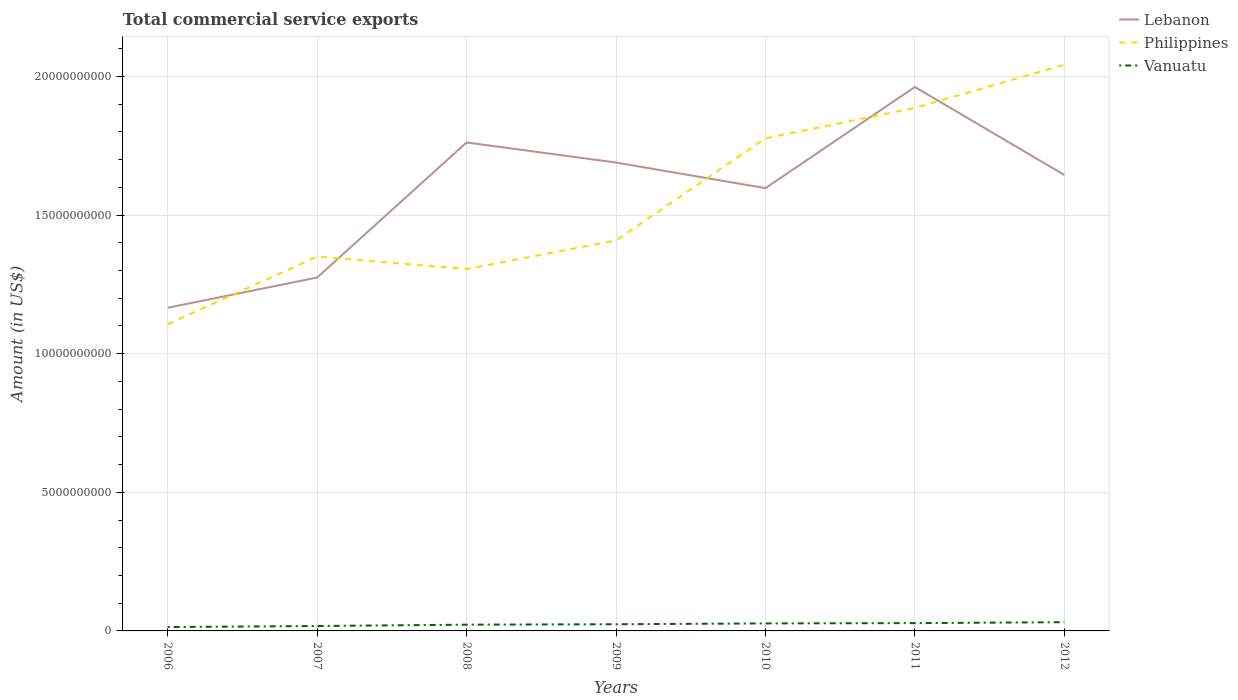Does the line corresponding to Vanuatu intersect with the line corresponding to Philippines?
Offer a terse response. No. Is the number of lines equal to the number of legend labels?
Make the answer very short. Yes. Across all years, what is the maximum total commercial service exports in Vanuatu?
Your response must be concise. 1.40e+08. In which year was the total commercial service exports in Lebanon maximum?
Your answer should be compact. 2006. What is the total total commercial service exports in Lebanon in the graph?
Keep it short and to the point. -4.31e+09. What is the difference between the highest and the second highest total commercial service exports in Lebanon?
Give a very brief answer. 7.96e+09. What is the difference between the highest and the lowest total commercial service exports in Lebanon?
Your response must be concise. 5. How many years are there in the graph?
Provide a short and direct response. 7. How are the legend labels stacked?
Your answer should be compact. Vertical. What is the title of the graph?
Your response must be concise. Total commercial service exports. Does "Belarus" appear as one of the legend labels in the graph?
Give a very brief answer. No. What is the label or title of the X-axis?
Give a very brief answer. Years. What is the Amount (in US$) of Lebanon in 2006?
Provide a succinct answer. 1.17e+1. What is the Amount (in US$) of Philippines in 2006?
Your answer should be very brief. 1.11e+1. What is the Amount (in US$) of Vanuatu in 2006?
Provide a succinct answer. 1.40e+08. What is the Amount (in US$) in Lebanon in 2007?
Your response must be concise. 1.27e+1. What is the Amount (in US$) of Philippines in 2007?
Provide a succinct answer. 1.35e+1. What is the Amount (in US$) of Vanuatu in 2007?
Make the answer very short. 1.77e+08. What is the Amount (in US$) of Lebanon in 2008?
Your answer should be compact. 1.76e+1. What is the Amount (in US$) of Philippines in 2008?
Give a very brief answer. 1.31e+1. What is the Amount (in US$) in Vanuatu in 2008?
Ensure brevity in your answer.  2.25e+08. What is the Amount (in US$) in Lebanon in 2009?
Your answer should be very brief. 1.69e+1. What is the Amount (in US$) in Philippines in 2009?
Keep it short and to the point. 1.41e+1. What is the Amount (in US$) in Vanuatu in 2009?
Give a very brief answer. 2.41e+08. What is the Amount (in US$) of Lebanon in 2010?
Provide a succinct answer. 1.60e+1. What is the Amount (in US$) of Philippines in 2010?
Ensure brevity in your answer.  1.78e+1. What is the Amount (in US$) in Vanuatu in 2010?
Your answer should be compact. 2.71e+08. What is the Amount (in US$) of Lebanon in 2011?
Offer a very short reply. 1.96e+1. What is the Amount (in US$) in Philippines in 2011?
Provide a succinct answer. 1.89e+1. What is the Amount (in US$) of Vanuatu in 2011?
Offer a very short reply. 2.81e+08. What is the Amount (in US$) of Lebanon in 2012?
Your answer should be very brief. 1.64e+1. What is the Amount (in US$) in Philippines in 2012?
Your answer should be very brief. 2.04e+1. What is the Amount (in US$) of Vanuatu in 2012?
Your response must be concise. 3.15e+08. Across all years, what is the maximum Amount (in US$) of Lebanon?
Keep it short and to the point. 1.96e+1. Across all years, what is the maximum Amount (in US$) in Philippines?
Your answer should be very brief. 2.04e+1. Across all years, what is the maximum Amount (in US$) in Vanuatu?
Ensure brevity in your answer.  3.15e+08. Across all years, what is the minimum Amount (in US$) of Lebanon?
Your response must be concise. 1.17e+1. Across all years, what is the minimum Amount (in US$) in Philippines?
Give a very brief answer. 1.11e+1. Across all years, what is the minimum Amount (in US$) in Vanuatu?
Keep it short and to the point. 1.40e+08. What is the total Amount (in US$) of Lebanon in the graph?
Offer a very short reply. 1.11e+11. What is the total Amount (in US$) of Philippines in the graph?
Ensure brevity in your answer.  1.09e+11. What is the total Amount (in US$) of Vanuatu in the graph?
Provide a short and direct response. 1.65e+09. What is the difference between the Amount (in US$) in Lebanon in 2006 and that in 2007?
Make the answer very short. -1.09e+09. What is the difference between the Amount (in US$) of Philippines in 2006 and that in 2007?
Ensure brevity in your answer.  -2.44e+09. What is the difference between the Amount (in US$) in Vanuatu in 2006 and that in 2007?
Make the answer very short. -3.69e+07. What is the difference between the Amount (in US$) of Lebanon in 2006 and that in 2008?
Ensure brevity in your answer.  -5.96e+09. What is the difference between the Amount (in US$) of Philippines in 2006 and that in 2008?
Give a very brief answer. -1.99e+09. What is the difference between the Amount (in US$) in Vanuatu in 2006 and that in 2008?
Give a very brief answer. -8.52e+07. What is the difference between the Amount (in US$) in Lebanon in 2006 and that in 2009?
Your answer should be compact. -5.24e+09. What is the difference between the Amount (in US$) in Philippines in 2006 and that in 2009?
Make the answer very short. -3.02e+09. What is the difference between the Amount (in US$) of Vanuatu in 2006 and that in 2009?
Your answer should be compact. -1.01e+08. What is the difference between the Amount (in US$) in Lebanon in 2006 and that in 2010?
Offer a terse response. -4.31e+09. What is the difference between the Amount (in US$) of Philippines in 2006 and that in 2010?
Provide a succinct answer. -6.71e+09. What is the difference between the Amount (in US$) in Vanuatu in 2006 and that in 2010?
Ensure brevity in your answer.  -1.31e+08. What is the difference between the Amount (in US$) of Lebanon in 2006 and that in 2011?
Give a very brief answer. -7.96e+09. What is the difference between the Amount (in US$) in Philippines in 2006 and that in 2011?
Provide a short and direct response. -7.80e+09. What is the difference between the Amount (in US$) in Vanuatu in 2006 and that in 2011?
Offer a terse response. -1.41e+08. What is the difference between the Amount (in US$) in Lebanon in 2006 and that in 2012?
Provide a short and direct response. -4.79e+09. What is the difference between the Amount (in US$) in Philippines in 2006 and that in 2012?
Keep it short and to the point. -9.36e+09. What is the difference between the Amount (in US$) of Vanuatu in 2006 and that in 2012?
Make the answer very short. -1.75e+08. What is the difference between the Amount (in US$) of Lebanon in 2007 and that in 2008?
Provide a succinct answer. -4.87e+09. What is the difference between the Amount (in US$) of Philippines in 2007 and that in 2008?
Make the answer very short. 4.47e+08. What is the difference between the Amount (in US$) in Vanuatu in 2007 and that in 2008?
Provide a succinct answer. -4.83e+07. What is the difference between the Amount (in US$) in Lebanon in 2007 and that in 2009?
Your answer should be compact. -4.15e+09. What is the difference between the Amount (in US$) in Philippines in 2007 and that in 2009?
Ensure brevity in your answer.  -5.82e+08. What is the difference between the Amount (in US$) of Vanuatu in 2007 and that in 2009?
Provide a short and direct response. -6.40e+07. What is the difference between the Amount (in US$) of Lebanon in 2007 and that in 2010?
Give a very brief answer. -3.22e+09. What is the difference between the Amount (in US$) of Philippines in 2007 and that in 2010?
Provide a succinct answer. -4.27e+09. What is the difference between the Amount (in US$) in Vanuatu in 2007 and that in 2010?
Your answer should be very brief. -9.42e+07. What is the difference between the Amount (in US$) in Lebanon in 2007 and that in 2011?
Your answer should be very brief. -6.87e+09. What is the difference between the Amount (in US$) in Philippines in 2007 and that in 2011?
Offer a terse response. -5.36e+09. What is the difference between the Amount (in US$) in Vanuatu in 2007 and that in 2011?
Provide a succinct answer. -1.04e+08. What is the difference between the Amount (in US$) in Lebanon in 2007 and that in 2012?
Offer a very short reply. -3.70e+09. What is the difference between the Amount (in US$) of Philippines in 2007 and that in 2012?
Keep it short and to the point. -6.92e+09. What is the difference between the Amount (in US$) of Vanuatu in 2007 and that in 2012?
Your response must be concise. -1.38e+08. What is the difference between the Amount (in US$) in Lebanon in 2008 and that in 2009?
Offer a very short reply. 7.25e+08. What is the difference between the Amount (in US$) of Philippines in 2008 and that in 2009?
Offer a very short reply. -1.03e+09. What is the difference between the Amount (in US$) of Vanuatu in 2008 and that in 2009?
Your answer should be compact. -1.57e+07. What is the difference between the Amount (in US$) in Lebanon in 2008 and that in 2010?
Provide a short and direct response. 1.65e+09. What is the difference between the Amount (in US$) in Philippines in 2008 and that in 2010?
Keep it short and to the point. -4.72e+09. What is the difference between the Amount (in US$) in Vanuatu in 2008 and that in 2010?
Ensure brevity in your answer.  -4.59e+07. What is the difference between the Amount (in US$) of Lebanon in 2008 and that in 2011?
Keep it short and to the point. -2.00e+09. What is the difference between the Amount (in US$) of Philippines in 2008 and that in 2011?
Give a very brief answer. -5.81e+09. What is the difference between the Amount (in US$) in Vanuatu in 2008 and that in 2011?
Your answer should be compact. -5.62e+07. What is the difference between the Amount (in US$) of Lebanon in 2008 and that in 2012?
Give a very brief answer. 1.17e+09. What is the difference between the Amount (in US$) in Philippines in 2008 and that in 2012?
Your answer should be very brief. -7.37e+09. What is the difference between the Amount (in US$) in Vanuatu in 2008 and that in 2012?
Ensure brevity in your answer.  -9.00e+07. What is the difference between the Amount (in US$) in Lebanon in 2009 and that in 2010?
Your answer should be compact. 9.23e+08. What is the difference between the Amount (in US$) in Philippines in 2009 and that in 2010?
Offer a very short reply. -3.69e+09. What is the difference between the Amount (in US$) of Vanuatu in 2009 and that in 2010?
Ensure brevity in your answer.  -3.02e+07. What is the difference between the Amount (in US$) in Lebanon in 2009 and that in 2011?
Provide a short and direct response. -2.73e+09. What is the difference between the Amount (in US$) in Philippines in 2009 and that in 2011?
Make the answer very short. -4.78e+09. What is the difference between the Amount (in US$) in Vanuatu in 2009 and that in 2011?
Provide a short and direct response. -4.05e+07. What is the difference between the Amount (in US$) of Lebanon in 2009 and that in 2012?
Provide a succinct answer. 4.48e+08. What is the difference between the Amount (in US$) of Philippines in 2009 and that in 2012?
Ensure brevity in your answer.  -6.34e+09. What is the difference between the Amount (in US$) in Vanuatu in 2009 and that in 2012?
Your answer should be very brief. -7.43e+07. What is the difference between the Amount (in US$) in Lebanon in 2010 and that in 2011?
Provide a short and direct response. -3.65e+09. What is the difference between the Amount (in US$) in Philippines in 2010 and that in 2011?
Your answer should be compact. -1.10e+09. What is the difference between the Amount (in US$) of Vanuatu in 2010 and that in 2011?
Provide a succinct answer. -1.03e+07. What is the difference between the Amount (in US$) of Lebanon in 2010 and that in 2012?
Your answer should be very brief. -4.75e+08. What is the difference between the Amount (in US$) of Philippines in 2010 and that in 2012?
Make the answer very short. -2.66e+09. What is the difference between the Amount (in US$) of Vanuatu in 2010 and that in 2012?
Provide a succinct answer. -4.41e+07. What is the difference between the Amount (in US$) of Lebanon in 2011 and that in 2012?
Your answer should be very brief. 3.17e+09. What is the difference between the Amount (in US$) in Philippines in 2011 and that in 2012?
Make the answer very short. -1.56e+09. What is the difference between the Amount (in US$) of Vanuatu in 2011 and that in 2012?
Ensure brevity in your answer.  -3.38e+07. What is the difference between the Amount (in US$) of Lebanon in 2006 and the Amount (in US$) of Philippines in 2007?
Your response must be concise. -1.84e+09. What is the difference between the Amount (in US$) in Lebanon in 2006 and the Amount (in US$) in Vanuatu in 2007?
Offer a very short reply. 1.15e+1. What is the difference between the Amount (in US$) of Philippines in 2006 and the Amount (in US$) of Vanuatu in 2007?
Offer a terse response. 1.09e+1. What is the difference between the Amount (in US$) in Lebanon in 2006 and the Amount (in US$) in Philippines in 2008?
Provide a short and direct response. -1.40e+09. What is the difference between the Amount (in US$) of Lebanon in 2006 and the Amount (in US$) of Vanuatu in 2008?
Offer a very short reply. 1.14e+1. What is the difference between the Amount (in US$) in Philippines in 2006 and the Amount (in US$) in Vanuatu in 2008?
Provide a short and direct response. 1.08e+1. What is the difference between the Amount (in US$) of Lebanon in 2006 and the Amount (in US$) of Philippines in 2009?
Provide a succinct answer. -2.43e+09. What is the difference between the Amount (in US$) in Lebanon in 2006 and the Amount (in US$) in Vanuatu in 2009?
Ensure brevity in your answer.  1.14e+1. What is the difference between the Amount (in US$) of Philippines in 2006 and the Amount (in US$) of Vanuatu in 2009?
Ensure brevity in your answer.  1.08e+1. What is the difference between the Amount (in US$) of Lebanon in 2006 and the Amount (in US$) of Philippines in 2010?
Offer a very short reply. -6.11e+09. What is the difference between the Amount (in US$) in Lebanon in 2006 and the Amount (in US$) in Vanuatu in 2010?
Provide a succinct answer. 1.14e+1. What is the difference between the Amount (in US$) of Philippines in 2006 and the Amount (in US$) of Vanuatu in 2010?
Keep it short and to the point. 1.08e+1. What is the difference between the Amount (in US$) in Lebanon in 2006 and the Amount (in US$) in Philippines in 2011?
Keep it short and to the point. -7.21e+09. What is the difference between the Amount (in US$) in Lebanon in 2006 and the Amount (in US$) in Vanuatu in 2011?
Offer a terse response. 1.14e+1. What is the difference between the Amount (in US$) in Philippines in 2006 and the Amount (in US$) in Vanuatu in 2011?
Offer a terse response. 1.08e+1. What is the difference between the Amount (in US$) of Lebanon in 2006 and the Amount (in US$) of Philippines in 2012?
Offer a very short reply. -8.77e+09. What is the difference between the Amount (in US$) in Lebanon in 2006 and the Amount (in US$) in Vanuatu in 2012?
Provide a short and direct response. 1.13e+1. What is the difference between the Amount (in US$) of Philippines in 2006 and the Amount (in US$) of Vanuatu in 2012?
Offer a very short reply. 1.07e+1. What is the difference between the Amount (in US$) of Lebanon in 2007 and the Amount (in US$) of Philippines in 2008?
Give a very brief answer. -3.07e+08. What is the difference between the Amount (in US$) in Lebanon in 2007 and the Amount (in US$) in Vanuatu in 2008?
Provide a short and direct response. 1.25e+1. What is the difference between the Amount (in US$) in Philippines in 2007 and the Amount (in US$) in Vanuatu in 2008?
Give a very brief answer. 1.33e+1. What is the difference between the Amount (in US$) of Lebanon in 2007 and the Amount (in US$) of Philippines in 2009?
Give a very brief answer. -1.34e+09. What is the difference between the Amount (in US$) in Lebanon in 2007 and the Amount (in US$) in Vanuatu in 2009?
Offer a very short reply. 1.25e+1. What is the difference between the Amount (in US$) of Philippines in 2007 and the Amount (in US$) of Vanuatu in 2009?
Provide a short and direct response. 1.33e+1. What is the difference between the Amount (in US$) in Lebanon in 2007 and the Amount (in US$) in Philippines in 2010?
Offer a very short reply. -5.02e+09. What is the difference between the Amount (in US$) in Lebanon in 2007 and the Amount (in US$) in Vanuatu in 2010?
Your answer should be very brief. 1.25e+1. What is the difference between the Amount (in US$) of Philippines in 2007 and the Amount (in US$) of Vanuatu in 2010?
Offer a very short reply. 1.32e+1. What is the difference between the Amount (in US$) in Lebanon in 2007 and the Amount (in US$) in Philippines in 2011?
Provide a short and direct response. -6.12e+09. What is the difference between the Amount (in US$) of Lebanon in 2007 and the Amount (in US$) of Vanuatu in 2011?
Keep it short and to the point. 1.25e+1. What is the difference between the Amount (in US$) of Philippines in 2007 and the Amount (in US$) of Vanuatu in 2011?
Your answer should be compact. 1.32e+1. What is the difference between the Amount (in US$) in Lebanon in 2007 and the Amount (in US$) in Philippines in 2012?
Give a very brief answer. -7.68e+09. What is the difference between the Amount (in US$) of Lebanon in 2007 and the Amount (in US$) of Vanuatu in 2012?
Offer a terse response. 1.24e+1. What is the difference between the Amount (in US$) of Philippines in 2007 and the Amount (in US$) of Vanuatu in 2012?
Provide a short and direct response. 1.32e+1. What is the difference between the Amount (in US$) of Lebanon in 2008 and the Amount (in US$) of Philippines in 2009?
Make the answer very short. 3.54e+09. What is the difference between the Amount (in US$) in Lebanon in 2008 and the Amount (in US$) in Vanuatu in 2009?
Give a very brief answer. 1.74e+1. What is the difference between the Amount (in US$) of Philippines in 2008 and the Amount (in US$) of Vanuatu in 2009?
Give a very brief answer. 1.28e+1. What is the difference between the Amount (in US$) of Lebanon in 2008 and the Amount (in US$) of Philippines in 2010?
Your answer should be very brief. -1.50e+08. What is the difference between the Amount (in US$) of Lebanon in 2008 and the Amount (in US$) of Vanuatu in 2010?
Your response must be concise. 1.73e+1. What is the difference between the Amount (in US$) in Philippines in 2008 and the Amount (in US$) in Vanuatu in 2010?
Offer a very short reply. 1.28e+1. What is the difference between the Amount (in US$) in Lebanon in 2008 and the Amount (in US$) in Philippines in 2011?
Offer a very short reply. -1.25e+09. What is the difference between the Amount (in US$) of Lebanon in 2008 and the Amount (in US$) of Vanuatu in 2011?
Offer a terse response. 1.73e+1. What is the difference between the Amount (in US$) of Philippines in 2008 and the Amount (in US$) of Vanuatu in 2011?
Make the answer very short. 1.28e+1. What is the difference between the Amount (in US$) of Lebanon in 2008 and the Amount (in US$) of Philippines in 2012?
Ensure brevity in your answer.  -2.81e+09. What is the difference between the Amount (in US$) of Lebanon in 2008 and the Amount (in US$) of Vanuatu in 2012?
Make the answer very short. 1.73e+1. What is the difference between the Amount (in US$) in Philippines in 2008 and the Amount (in US$) in Vanuatu in 2012?
Ensure brevity in your answer.  1.27e+1. What is the difference between the Amount (in US$) of Lebanon in 2009 and the Amount (in US$) of Philippines in 2010?
Offer a very short reply. -8.75e+08. What is the difference between the Amount (in US$) of Lebanon in 2009 and the Amount (in US$) of Vanuatu in 2010?
Your answer should be very brief. 1.66e+1. What is the difference between the Amount (in US$) in Philippines in 2009 and the Amount (in US$) in Vanuatu in 2010?
Keep it short and to the point. 1.38e+1. What is the difference between the Amount (in US$) in Lebanon in 2009 and the Amount (in US$) in Philippines in 2011?
Make the answer very short. -1.97e+09. What is the difference between the Amount (in US$) of Lebanon in 2009 and the Amount (in US$) of Vanuatu in 2011?
Provide a succinct answer. 1.66e+1. What is the difference between the Amount (in US$) of Philippines in 2009 and the Amount (in US$) of Vanuatu in 2011?
Give a very brief answer. 1.38e+1. What is the difference between the Amount (in US$) of Lebanon in 2009 and the Amount (in US$) of Philippines in 2012?
Your answer should be very brief. -3.53e+09. What is the difference between the Amount (in US$) in Lebanon in 2009 and the Amount (in US$) in Vanuatu in 2012?
Your answer should be very brief. 1.66e+1. What is the difference between the Amount (in US$) of Philippines in 2009 and the Amount (in US$) of Vanuatu in 2012?
Provide a short and direct response. 1.38e+1. What is the difference between the Amount (in US$) of Lebanon in 2010 and the Amount (in US$) of Philippines in 2011?
Give a very brief answer. -2.89e+09. What is the difference between the Amount (in US$) of Lebanon in 2010 and the Amount (in US$) of Vanuatu in 2011?
Your response must be concise. 1.57e+1. What is the difference between the Amount (in US$) in Philippines in 2010 and the Amount (in US$) in Vanuatu in 2011?
Offer a terse response. 1.75e+1. What is the difference between the Amount (in US$) in Lebanon in 2010 and the Amount (in US$) in Philippines in 2012?
Make the answer very short. -4.45e+09. What is the difference between the Amount (in US$) in Lebanon in 2010 and the Amount (in US$) in Vanuatu in 2012?
Provide a succinct answer. 1.57e+1. What is the difference between the Amount (in US$) in Philippines in 2010 and the Amount (in US$) in Vanuatu in 2012?
Keep it short and to the point. 1.75e+1. What is the difference between the Amount (in US$) of Lebanon in 2011 and the Amount (in US$) of Philippines in 2012?
Make the answer very short. -8.04e+08. What is the difference between the Amount (in US$) of Lebanon in 2011 and the Amount (in US$) of Vanuatu in 2012?
Make the answer very short. 1.93e+1. What is the difference between the Amount (in US$) in Philippines in 2011 and the Amount (in US$) in Vanuatu in 2012?
Your response must be concise. 1.86e+1. What is the average Amount (in US$) in Lebanon per year?
Give a very brief answer. 1.59e+1. What is the average Amount (in US$) in Philippines per year?
Your response must be concise. 1.55e+1. What is the average Amount (in US$) in Vanuatu per year?
Provide a short and direct response. 2.36e+08. In the year 2006, what is the difference between the Amount (in US$) in Lebanon and Amount (in US$) in Philippines?
Give a very brief answer. 5.93e+08. In the year 2006, what is the difference between the Amount (in US$) in Lebanon and Amount (in US$) in Vanuatu?
Offer a very short reply. 1.15e+1. In the year 2006, what is the difference between the Amount (in US$) of Philippines and Amount (in US$) of Vanuatu?
Make the answer very short. 1.09e+1. In the year 2007, what is the difference between the Amount (in US$) of Lebanon and Amount (in US$) of Philippines?
Make the answer very short. -7.54e+08. In the year 2007, what is the difference between the Amount (in US$) of Lebanon and Amount (in US$) of Vanuatu?
Provide a succinct answer. 1.26e+1. In the year 2007, what is the difference between the Amount (in US$) of Philippines and Amount (in US$) of Vanuatu?
Your answer should be very brief. 1.33e+1. In the year 2008, what is the difference between the Amount (in US$) in Lebanon and Amount (in US$) in Philippines?
Your response must be concise. 4.57e+09. In the year 2008, what is the difference between the Amount (in US$) of Lebanon and Amount (in US$) of Vanuatu?
Give a very brief answer. 1.74e+1. In the year 2008, what is the difference between the Amount (in US$) of Philippines and Amount (in US$) of Vanuatu?
Provide a short and direct response. 1.28e+1. In the year 2009, what is the difference between the Amount (in US$) of Lebanon and Amount (in US$) of Philippines?
Your answer should be very brief. 2.81e+09. In the year 2009, what is the difference between the Amount (in US$) of Lebanon and Amount (in US$) of Vanuatu?
Your answer should be very brief. 1.67e+1. In the year 2009, what is the difference between the Amount (in US$) in Philippines and Amount (in US$) in Vanuatu?
Your response must be concise. 1.38e+1. In the year 2010, what is the difference between the Amount (in US$) in Lebanon and Amount (in US$) in Philippines?
Make the answer very short. -1.80e+09. In the year 2010, what is the difference between the Amount (in US$) of Lebanon and Amount (in US$) of Vanuatu?
Offer a very short reply. 1.57e+1. In the year 2010, what is the difference between the Amount (in US$) of Philippines and Amount (in US$) of Vanuatu?
Offer a very short reply. 1.75e+1. In the year 2011, what is the difference between the Amount (in US$) of Lebanon and Amount (in US$) of Philippines?
Offer a very short reply. 7.55e+08. In the year 2011, what is the difference between the Amount (in US$) in Lebanon and Amount (in US$) in Vanuatu?
Ensure brevity in your answer.  1.93e+1. In the year 2011, what is the difference between the Amount (in US$) in Philippines and Amount (in US$) in Vanuatu?
Your answer should be compact. 1.86e+1. In the year 2012, what is the difference between the Amount (in US$) of Lebanon and Amount (in US$) of Philippines?
Offer a terse response. -3.98e+09. In the year 2012, what is the difference between the Amount (in US$) in Lebanon and Amount (in US$) in Vanuatu?
Keep it short and to the point. 1.61e+1. In the year 2012, what is the difference between the Amount (in US$) in Philippines and Amount (in US$) in Vanuatu?
Your response must be concise. 2.01e+1. What is the ratio of the Amount (in US$) of Lebanon in 2006 to that in 2007?
Give a very brief answer. 0.91. What is the ratio of the Amount (in US$) in Philippines in 2006 to that in 2007?
Your answer should be very brief. 0.82. What is the ratio of the Amount (in US$) in Vanuatu in 2006 to that in 2007?
Your answer should be compact. 0.79. What is the ratio of the Amount (in US$) in Lebanon in 2006 to that in 2008?
Your response must be concise. 0.66. What is the ratio of the Amount (in US$) in Philippines in 2006 to that in 2008?
Give a very brief answer. 0.85. What is the ratio of the Amount (in US$) in Vanuatu in 2006 to that in 2008?
Ensure brevity in your answer.  0.62. What is the ratio of the Amount (in US$) in Lebanon in 2006 to that in 2009?
Give a very brief answer. 0.69. What is the ratio of the Amount (in US$) in Philippines in 2006 to that in 2009?
Offer a very short reply. 0.79. What is the ratio of the Amount (in US$) in Vanuatu in 2006 to that in 2009?
Ensure brevity in your answer.  0.58. What is the ratio of the Amount (in US$) in Lebanon in 2006 to that in 2010?
Provide a short and direct response. 0.73. What is the ratio of the Amount (in US$) of Philippines in 2006 to that in 2010?
Provide a short and direct response. 0.62. What is the ratio of the Amount (in US$) in Vanuatu in 2006 to that in 2010?
Offer a very short reply. 0.52. What is the ratio of the Amount (in US$) in Lebanon in 2006 to that in 2011?
Ensure brevity in your answer.  0.59. What is the ratio of the Amount (in US$) of Philippines in 2006 to that in 2011?
Your answer should be very brief. 0.59. What is the ratio of the Amount (in US$) in Vanuatu in 2006 to that in 2011?
Your answer should be compact. 0.5. What is the ratio of the Amount (in US$) in Lebanon in 2006 to that in 2012?
Your answer should be very brief. 0.71. What is the ratio of the Amount (in US$) in Philippines in 2006 to that in 2012?
Ensure brevity in your answer.  0.54. What is the ratio of the Amount (in US$) in Vanuatu in 2006 to that in 2012?
Provide a succinct answer. 0.44. What is the ratio of the Amount (in US$) of Lebanon in 2007 to that in 2008?
Your answer should be compact. 0.72. What is the ratio of the Amount (in US$) of Philippines in 2007 to that in 2008?
Give a very brief answer. 1.03. What is the ratio of the Amount (in US$) of Vanuatu in 2007 to that in 2008?
Ensure brevity in your answer.  0.79. What is the ratio of the Amount (in US$) of Lebanon in 2007 to that in 2009?
Offer a very short reply. 0.75. What is the ratio of the Amount (in US$) of Philippines in 2007 to that in 2009?
Your response must be concise. 0.96. What is the ratio of the Amount (in US$) in Vanuatu in 2007 to that in 2009?
Make the answer very short. 0.73. What is the ratio of the Amount (in US$) in Lebanon in 2007 to that in 2010?
Keep it short and to the point. 0.8. What is the ratio of the Amount (in US$) of Philippines in 2007 to that in 2010?
Offer a very short reply. 0.76. What is the ratio of the Amount (in US$) of Vanuatu in 2007 to that in 2010?
Your answer should be compact. 0.65. What is the ratio of the Amount (in US$) in Lebanon in 2007 to that in 2011?
Your answer should be compact. 0.65. What is the ratio of the Amount (in US$) in Philippines in 2007 to that in 2011?
Give a very brief answer. 0.72. What is the ratio of the Amount (in US$) of Vanuatu in 2007 to that in 2011?
Offer a very short reply. 0.63. What is the ratio of the Amount (in US$) of Lebanon in 2007 to that in 2012?
Your answer should be very brief. 0.78. What is the ratio of the Amount (in US$) in Philippines in 2007 to that in 2012?
Offer a very short reply. 0.66. What is the ratio of the Amount (in US$) in Vanuatu in 2007 to that in 2012?
Offer a terse response. 0.56. What is the ratio of the Amount (in US$) of Lebanon in 2008 to that in 2009?
Your answer should be very brief. 1.04. What is the ratio of the Amount (in US$) of Philippines in 2008 to that in 2009?
Offer a very short reply. 0.93. What is the ratio of the Amount (in US$) in Vanuatu in 2008 to that in 2009?
Keep it short and to the point. 0.93. What is the ratio of the Amount (in US$) in Lebanon in 2008 to that in 2010?
Make the answer very short. 1.1. What is the ratio of the Amount (in US$) of Philippines in 2008 to that in 2010?
Offer a very short reply. 0.73. What is the ratio of the Amount (in US$) of Vanuatu in 2008 to that in 2010?
Keep it short and to the point. 0.83. What is the ratio of the Amount (in US$) of Lebanon in 2008 to that in 2011?
Your response must be concise. 0.9. What is the ratio of the Amount (in US$) in Philippines in 2008 to that in 2011?
Make the answer very short. 0.69. What is the ratio of the Amount (in US$) of Vanuatu in 2008 to that in 2011?
Your answer should be compact. 0.8. What is the ratio of the Amount (in US$) in Lebanon in 2008 to that in 2012?
Offer a very short reply. 1.07. What is the ratio of the Amount (in US$) of Philippines in 2008 to that in 2012?
Keep it short and to the point. 0.64. What is the ratio of the Amount (in US$) in Vanuatu in 2008 to that in 2012?
Your answer should be very brief. 0.71. What is the ratio of the Amount (in US$) of Lebanon in 2009 to that in 2010?
Make the answer very short. 1.06. What is the ratio of the Amount (in US$) of Philippines in 2009 to that in 2010?
Your answer should be very brief. 0.79. What is the ratio of the Amount (in US$) of Vanuatu in 2009 to that in 2010?
Make the answer very short. 0.89. What is the ratio of the Amount (in US$) of Lebanon in 2009 to that in 2011?
Keep it short and to the point. 0.86. What is the ratio of the Amount (in US$) of Philippines in 2009 to that in 2011?
Your response must be concise. 0.75. What is the ratio of the Amount (in US$) of Vanuatu in 2009 to that in 2011?
Provide a succinct answer. 0.86. What is the ratio of the Amount (in US$) in Lebanon in 2009 to that in 2012?
Provide a succinct answer. 1.03. What is the ratio of the Amount (in US$) in Philippines in 2009 to that in 2012?
Your response must be concise. 0.69. What is the ratio of the Amount (in US$) in Vanuatu in 2009 to that in 2012?
Your response must be concise. 0.76. What is the ratio of the Amount (in US$) of Lebanon in 2010 to that in 2011?
Give a very brief answer. 0.81. What is the ratio of the Amount (in US$) of Philippines in 2010 to that in 2011?
Offer a terse response. 0.94. What is the ratio of the Amount (in US$) in Vanuatu in 2010 to that in 2011?
Your response must be concise. 0.96. What is the ratio of the Amount (in US$) in Lebanon in 2010 to that in 2012?
Make the answer very short. 0.97. What is the ratio of the Amount (in US$) of Philippines in 2010 to that in 2012?
Ensure brevity in your answer.  0.87. What is the ratio of the Amount (in US$) in Vanuatu in 2010 to that in 2012?
Your answer should be compact. 0.86. What is the ratio of the Amount (in US$) of Lebanon in 2011 to that in 2012?
Provide a succinct answer. 1.19. What is the ratio of the Amount (in US$) in Philippines in 2011 to that in 2012?
Provide a succinct answer. 0.92. What is the ratio of the Amount (in US$) of Vanuatu in 2011 to that in 2012?
Offer a very short reply. 0.89. What is the difference between the highest and the second highest Amount (in US$) in Lebanon?
Provide a short and direct response. 2.00e+09. What is the difference between the highest and the second highest Amount (in US$) in Philippines?
Provide a succinct answer. 1.56e+09. What is the difference between the highest and the second highest Amount (in US$) in Vanuatu?
Your response must be concise. 3.38e+07. What is the difference between the highest and the lowest Amount (in US$) of Lebanon?
Offer a very short reply. 7.96e+09. What is the difference between the highest and the lowest Amount (in US$) in Philippines?
Your answer should be very brief. 9.36e+09. What is the difference between the highest and the lowest Amount (in US$) of Vanuatu?
Your answer should be very brief. 1.75e+08. 